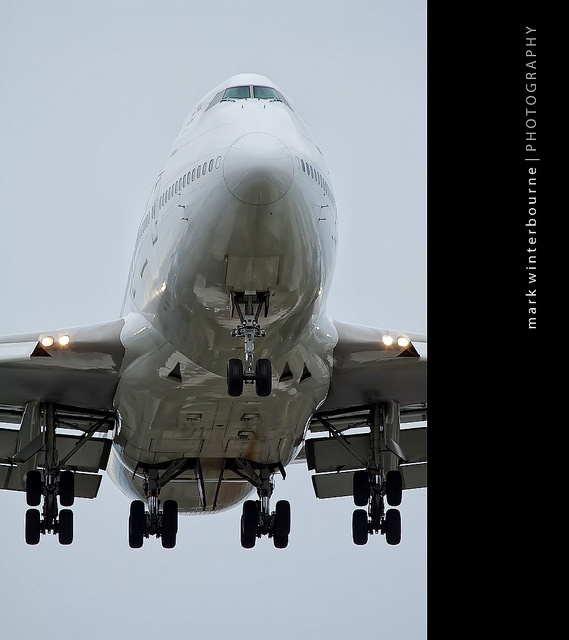Describe the objects in this image and their specific colors. I can see a airplane in lightgray, black, and gray tones in this image. 